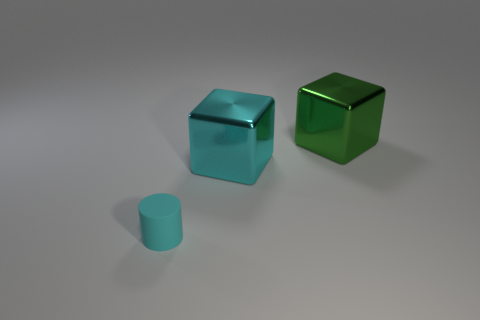Are any shiny balls visible?
Your response must be concise. No. What is the material of the large block that is the same color as the tiny object?
Provide a succinct answer. Metal. What number of objects are gray matte cylinders or green metal blocks?
Give a very brief answer. 1. Are there any other cylinders of the same color as the small cylinder?
Give a very brief answer. No. There is a big block that is on the right side of the big cyan object; what number of green objects are left of it?
Offer a very short reply. 0. Are there more big yellow rubber objects than small cyan rubber things?
Provide a short and direct response. No. Does the big green thing have the same material as the small cylinder?
Your answer should be very brief. No. Are there an equal number of cyan things that are behind the green metal thing and large cyan cubes?
Make the answer very short. No. What number of other blocks have the same material as the cyan block?
Offer a very short reply. 1. Is the number of large cyan cubes less than the number of metallic objects?
Your answer should be compact. Yes. 